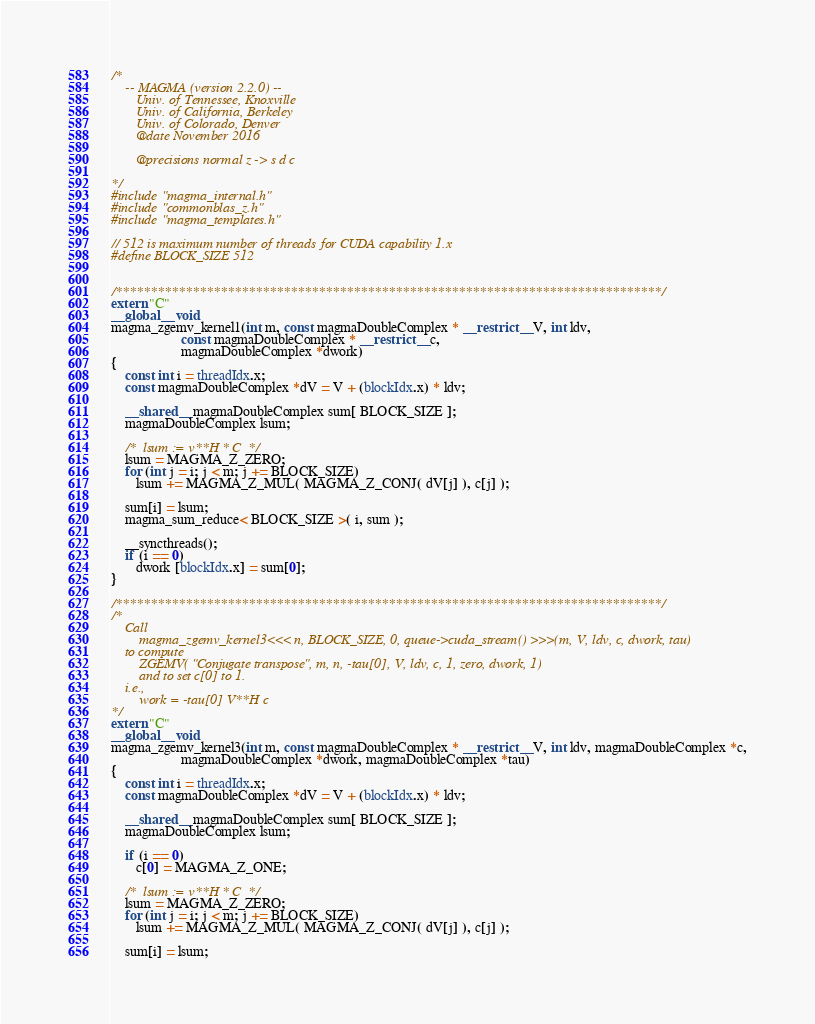<code> <loc_0><loc_0><loc_500><loc_500><_Cuda_>/*
    -- MAGMA (version 2.2.0) --
       Univ. of Tennessee, Knoxville
       Univ. of California, Berkeley
       Univ. of Colorado, Denver
       @date November 2016

       @precisions normal z -> s d c

*/
#include "magma_internal.h"
#include "commonblas_z.h"
#include "magma_templates.h"

// 512 is maximum number of threads for CUDA capability 1.x
#define BLOCK_SIZE 512


/******************************************************************************/
extern "C"
__global__ void 
magma_zgemv_kernel1(int m, const magmaDoubleComplex * __restrict__ V, int ldv, 
                    const magmaDoubleComplex * __restrict__ c, 
                    magmaDoubleComplex *dwork)
{
    const int i = threadIdx.x;
    const magmaDoubleComplex *dV = V + (blockIdx.x) * ldv;

    __shared__ magmaDoubleComplex sum[ BLOCK_SIZE ];
    magmaDoubleComplex lsum;

    /*  lsum := v**H * C  */
    lsum = MAGMA_Z_ZERO;
    for (int j = i; j < m; j += BLOCK_SIZE)
       lsum += MAGMA_Z_MUL( MAGMA_Z_CONJ( dV[j] ), c[j] );
    
    sum[i] = lsum;
    magma_sum_reduce< BLOCK_SIZE >( i, sum );

    __syncthreads();
    if (i == 0)
       dwork [blockIdx.x] = sum[0];
}

/******************************************************************************/
/*
    Call 
        magma_zgemv_kernel3<<< n, BLOCK_SIZE, 0, queue->cuda_stream() >>>(m, V, ldv, c, dwork, tau)
    to compute
        ZGEMV( "Conjugate transpose", m, n, -tau[0], V, ldv, c, 1, zero, dwork, 1)
        and to set c[0] to 1.
    i.e., 
        work = -tau[0] V**H c
*/
extern "C"
__global__ void
magma_zgemv_kernel3(int m, const magmaDoubleComplex * __restrict__ V, int ldv, magmaDoubleComplex *c,
                    magmaDoubleComplex *dwork, magmaDoubleComplex *tau)
{
    const int i = threadIdx.x;
    const magmaDoubleComplex *dV = V + (blockIdx.x) * ldv;

    __shared__ magmaDoubleComplex sum[ BLOCK_SIZE ];
    magmaDoubleComplex lsum;

    if (i == 0)
       c[0] = MAGMA_Z_ONE;           

    /*  lsum := v**H * C  */
    lsum = MAGMA_Z_ZERO;
    for (int j = i; j < m; j += BLOCK_SIZE)
       lsum += MAGMA_Z_MUL( MAGMA_Z_CONJ( dV[j] ), c[j] );

    sum[i] = lsum;</code> 